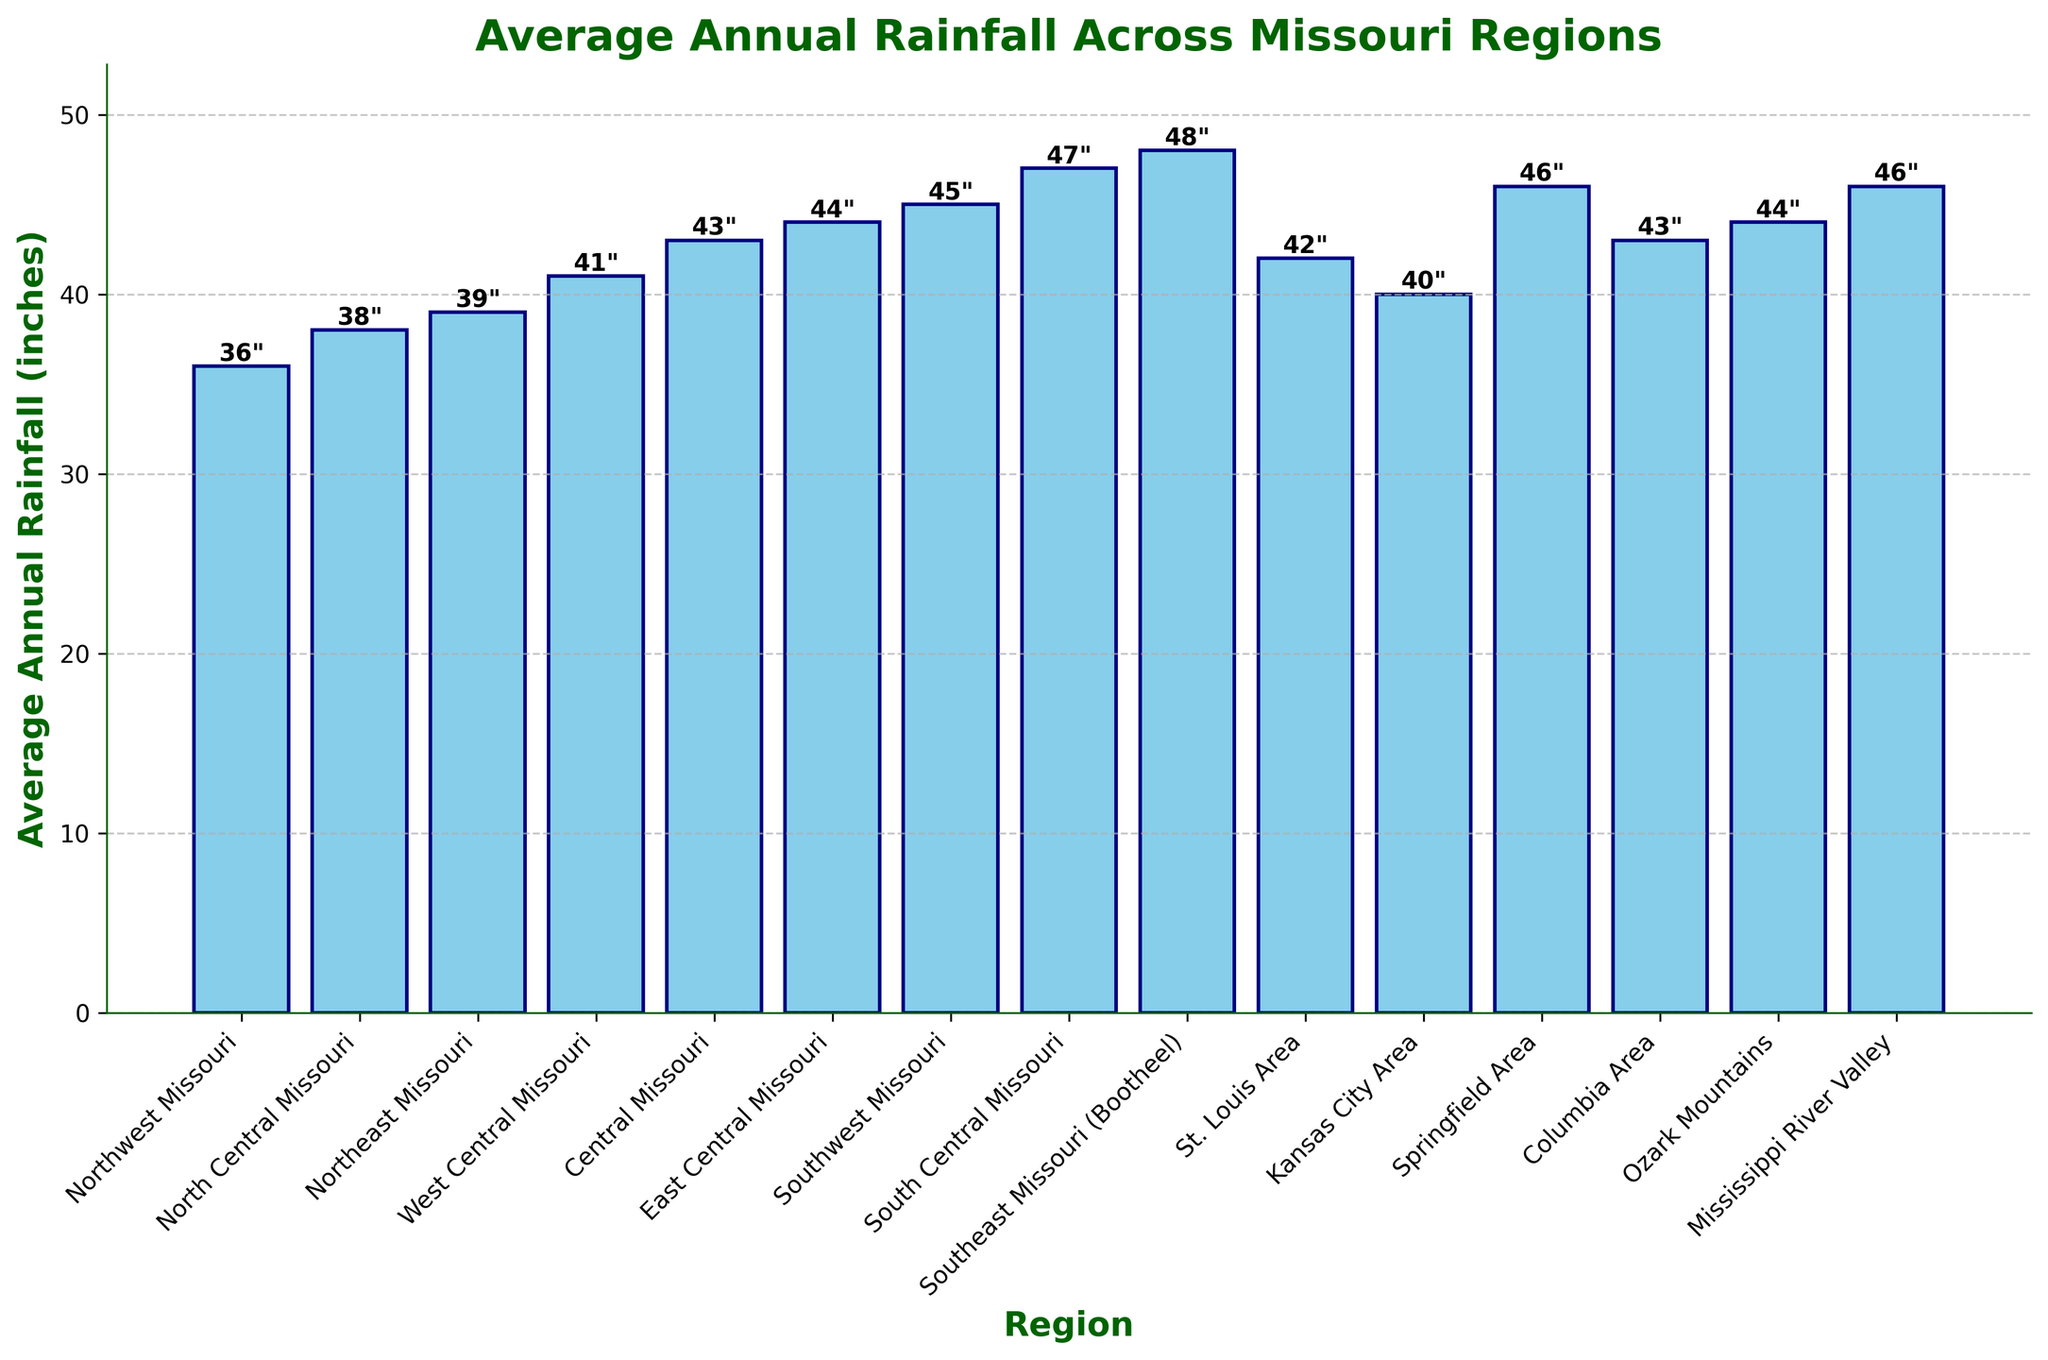What's the region with the highest average annual rainfall? Observe the bar representing each region and identify the tallest one, which visually indicates the highest value. The Southeast Missouri (Bootheel) region has the tallest bar at 48 inches.
Answer: Southeast Missouri (Bootheel) What's the difference in average annual rainfall between North Central Missouri and Central Missouri? Identify the bars for North Central Missouri and Central Missouri, then subtract the height of North Central Missouri's bar (38 inches) from Central Missouri's bar (43 inches). The difference is 43 - 38 = 5 inches.
Answer: 5 inches Which region receives more rainfall, Kansas City Area or Columbia Area? Compare the heights of the bars for Kansas City Area and Columbia Area. Kansas City Area has 40 inches and Columbia Area has 43 inches, so Columbia Area receives more rainfall.
Answer: Columbia Area What is the combined average annual rainfall for South Central Missouri and Springfield Area? Identify the rainfall values for South Central Missouri and Springfield Area. Then, add these values: 47 inches (South Central Missouri) + 46 inches (Springfield Area) = 93 inches.
Answer: 93 inches What's the average rainfall across all regions displayed in the figure? Sum the rainfall values for all regions and divide by the number of regions. The calculation is: (36 + 38 + 39 + 41 + 43 + 44 + 45 + 47 + 48 + 42 + 40 + 46 + 43 + 44 + 46) / 15 = 42 inches.
Answer: 42 inches Which region has less rainfall, East Central Missouri or the Ozark Mountains? Compare the heights of the bars for East Central Missouri and the Ozark Mountains. Both regions have the same rainfall value of 44 inches.
Answer: They are equal (44 inches) What is the range of the average annual rainfall values across all regions? Determine the highest and lowest rainfall values. The highest value is 48 inches (Southeast Missouri) and the lowest is 36 inches (Northwest Missouri). Subtract the smallest value from the largest to get the range. So, 48 - 36 = 12 inches.
Answer: 12 inches 